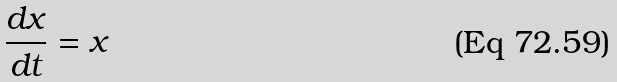Convert formula to latex. <formula><loc_0><loc_0><loc_500><loc_500>\frac { d x } { d t } = x</formula> 